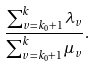Convert formula to latex. <formula><loc_0><loc_0><loc_500><loc_500>\frac { \sum _ { v = k _ { 0 } + 1 } ^ { k } \lambda _ { v } } { \sum _ { v = k _ { 0 } + 1 } ^ { k } \mu _ { v } } .</formula> 